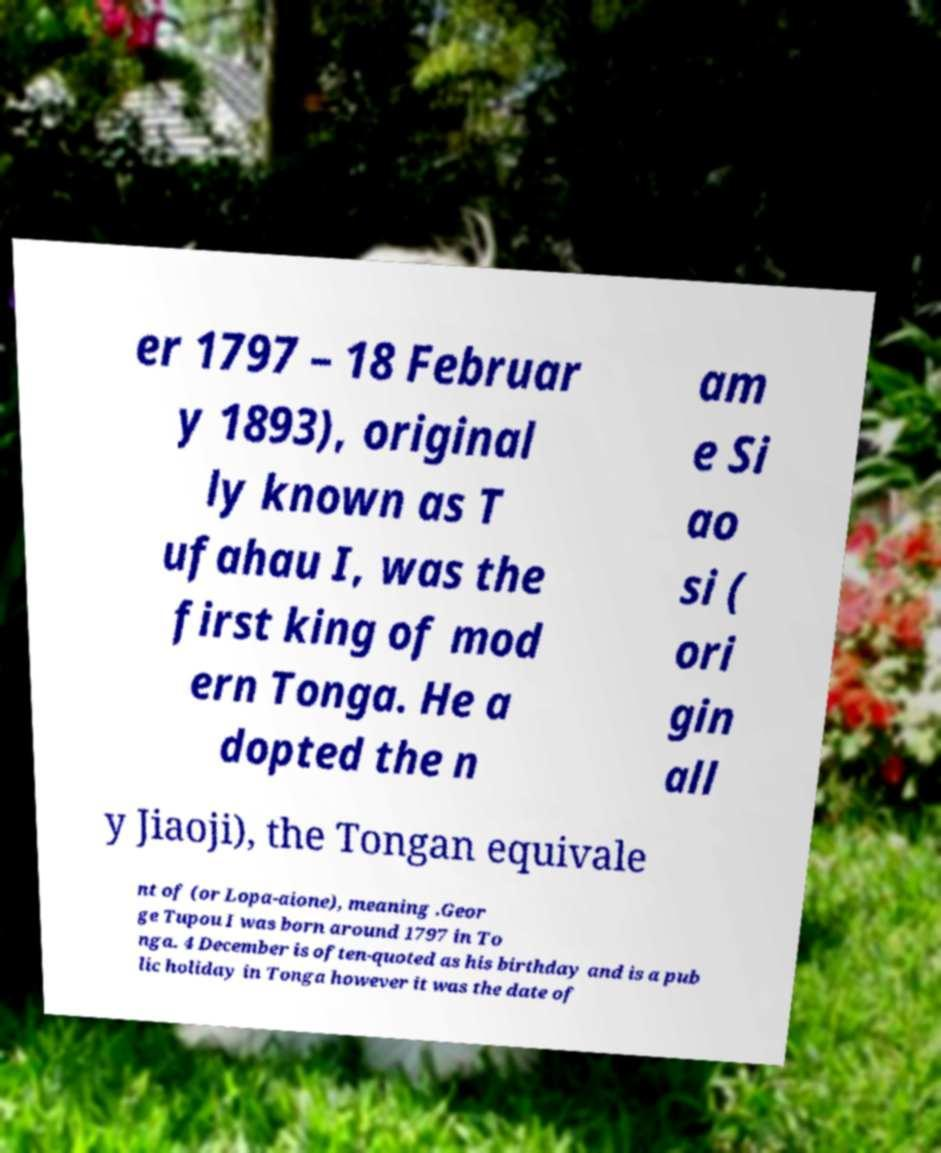I need the written content from this picture converted into text. Can you do that? er 1797 – 18 Februar y 1893), original ly known as T ufahau I, was the first king of mod ern Tonga. He a dopted the n am e Si ao si ( ori gin all y Jiaoji), the Tongan equivale nt of (or Lopa-aione), meaning .Geor ge Tupou I was born around 1797 in To nga. 4 December is often-quoted as his birthday and is a pub lic holiday in Tonga however it was the date of 